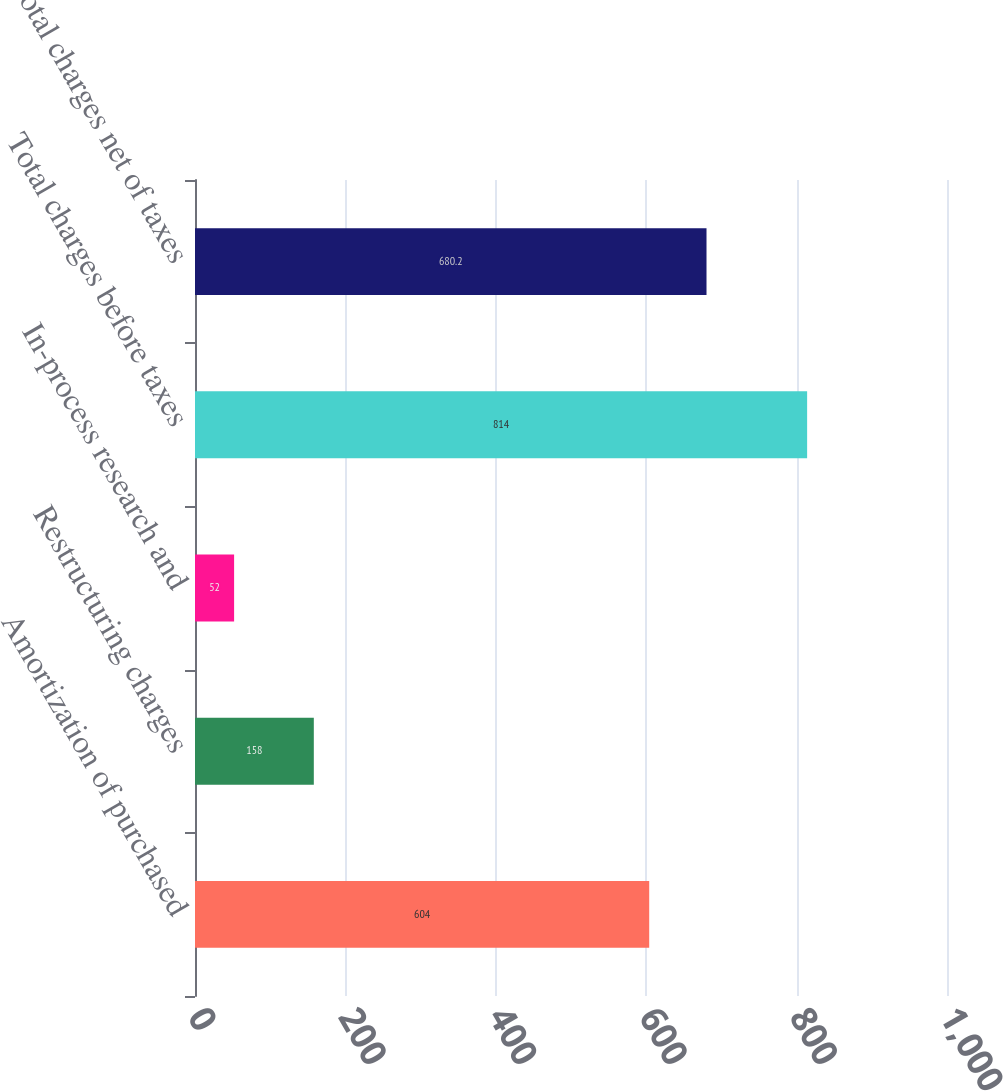<chart> <loc_0><loc_0><loc_500><loc_500><bar_chart><fcel>Amortization of purchased<fcel>Restructuring charges<fcel>In-process research and<fcel>Total charges before taxes<fcel>Total charges net of taxes<nl><fcel>604<fcel>158<fcel>52<fcel>814<fcel>680.2<nl></chart> 